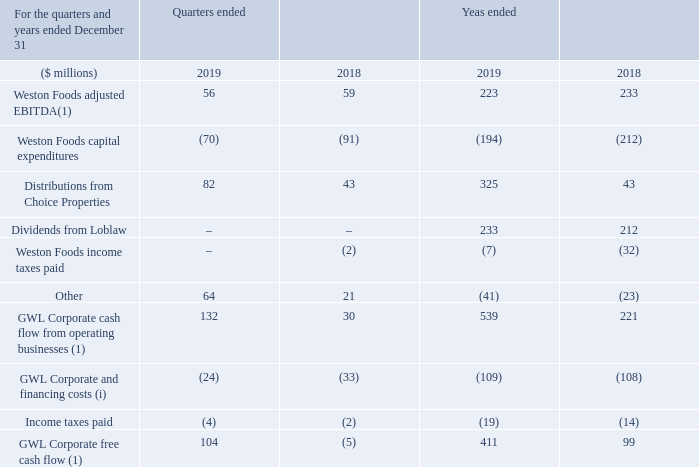GWL Corporate Free Cash Flow(1)
Following the reorganization of Choice Properties to GWL, management evaluates the cash generating capabilities of GWL Corporate(2) based on the various cash flow streams it receives from its operating subsidiaries. As a result, the GWL Corporate free cash flow(1) is based on the dividends received from Loblaw, distributions received from Choice Properties and net cash flow contributions received from Weston Foods less corporate expenses, interest and income taxes paid. Lease payments are excluded from the calculation of GWL Corporate free cash flow(1) to normalize for the impact of the implementation of IFRS 16.
(i) Included in Other and Intersegment, GWL Corporate includes all other company level activities that are not allocated to the reportable operating segments, such as net interest expense, corporate activities and administrative costs. Also included are preferred share dividends paid.
What is the basis for evaluation of cash generating capabilities of GWL? Based on the various cash flow streams it receives from its operating subsidiaries. What is the GWL Corporate free cash flow based on? Based on the dividends received from loblaw, distributions received from choice properties and net cash flow contributions received from weston foods less corporate expenses, interest and income taxes paid. What additional items are included in Other and Intersegment of GWL Corporate? Includes all other company level activities that are not allocated to the reportable operating segments, such as net interest expense, corporate activities and administrative costs. also included are preferred share dividends paid. What is the increase / (decrease) in the Weston Foods adjusted EBITDA from 2018 to 2019?
Answer scale should be: million. 56 - 59
Answer: -3. What is the average Distributions from Choice Properties for quarters ended in 2019 and 2018?
Answer scale should be: million. (82 + 43) / 2
Answer: 62.5. What is the percentage increase in the GWL Corporate cash flow from operating businesses for quarters ended 2018 to 2019?
Answer scale should be: percent. 132 / 30 - 1
Answer: 340. 